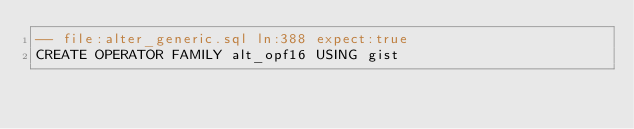Convert code to text. <code><loc_0><loc_0><loc_500><loc_500><_SQL_>-- file:alter_generic.sql ln:388 expect:true
CREATE OPERATOR FAMILY alt_opf16 USING gist
</code> 